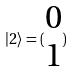<formula> <loc_0><loc_0><loc_500><loc_500>| 2 \rangle = ( \begin{matrix} 0 \\ 1 \end{matrix} )</formula> 